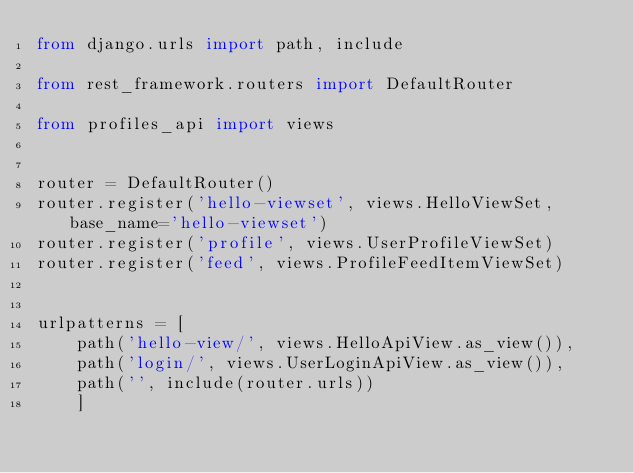<code> <loc_0><loc_0><loc_500><loc_500><_Python_>from django.urls import path, include

from rest_framework.routers import DefaultRouter

from profiles_api import views


router = DefaultRouter()
router.register('hello-viewset', views.HelloViewSet, base_name='hello-viewset')
router.register('profile', views.UserProfileViewSet)
router.register('feed', views.ProfileFeedItemViewSet)


urlpatterns = [
    path('hello-view/', views.HelloApiView.as_view()),
    path('login/', views.UserLoginApiView.as_view()),
    path('', include(router.urls))
    ]</code> 